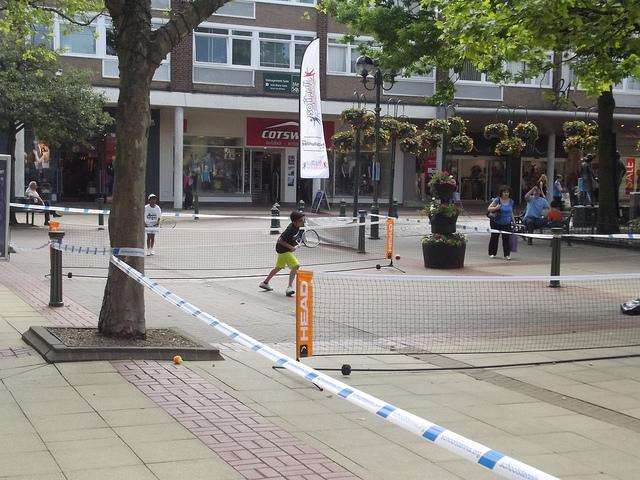Who is playing tennis with the boy wearing yellow pants? Please explain your reasoning. woman. A woman is standing on the other side of a tennis court from a boy in yellow. 